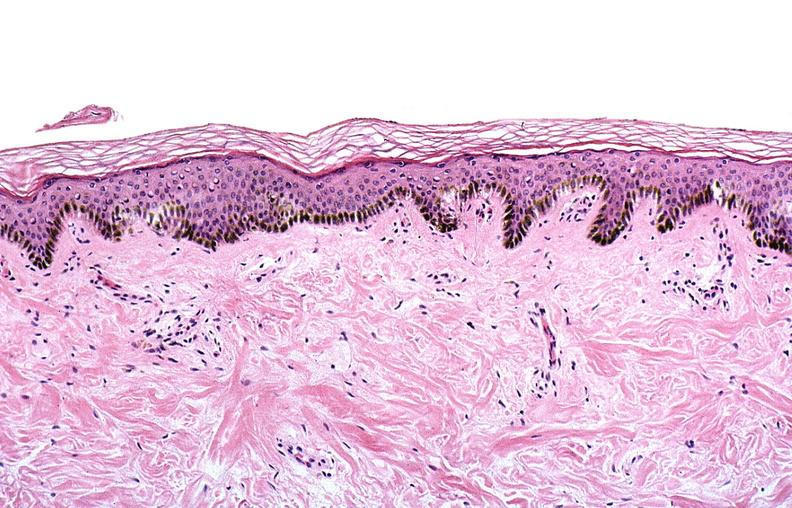where is this?
Answer the question using a single word or phrase. Skin 